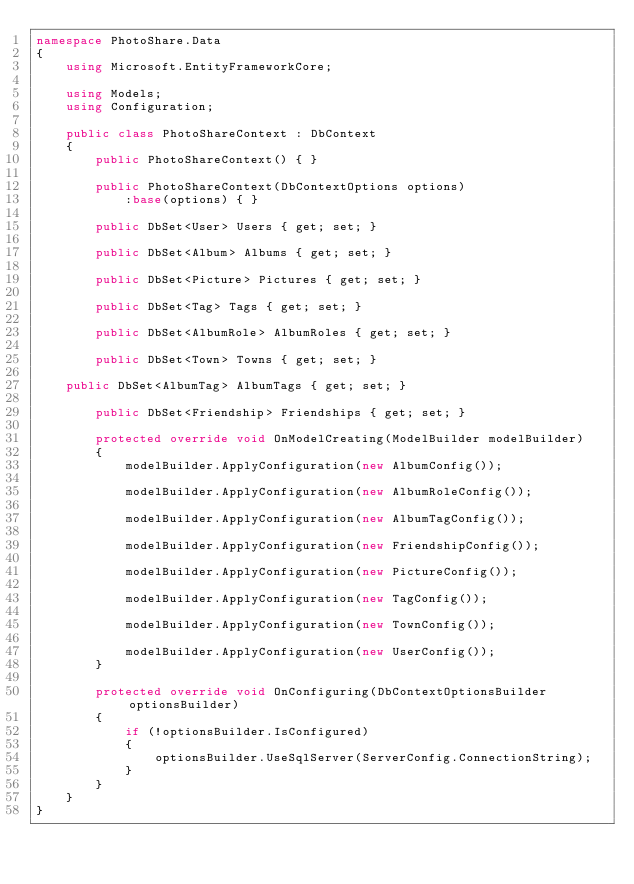<code> <loc_0><loc_0><loc_500><loc_500><_C#_>namespace PhotoShare.Data
{
    using Microsoft.EntityFrameworkCore;

    using Models;
    using Configuration;

    public class PhotoShareContext : DbContext
    { 
        public PhotoShareContext() { }

        public PhotoShareContext(DbContextOptions options)
            :base(options) { }

        public DbSet<User> Users { get; set; }

        public DbSet<Album> Albums { get; set; }

        public DbSet<Picture> Pictures { get; set; }

        public DbSet<Tag> Tags { get; set; }

        public DbSet<AlbumRole> AlbumRoles { get; set; }

        public DbSet<Town> Towns { get; set; }
		
		public DbSet<AlbumTag> AlbumTags { get; set; }

        public DbSet<Friendship> Friendships { get; set; }

        protected override void OnModelCreating(ModelBuilder modelBuilder)
        {
            modelBuilder.ApplyConfiguration(new AlbumConfig());

            modelBuilder.ApplyConfiguration(new AlbumRoleConfig());

            modelBuilder.ApplyConfiguration(new AlbumTagConfig());

            modelBuilder.ApplyConfiguration(new FriendshipConfig());

            modelBuilder.ApplyConfiguration(new PictureConfig());

            modelBuilder.ApplyConfiguration(new TagConfig());

            modelBuilder.ApplyConfiguration(new TownConfig());

            modelBuilder.ApplyConfiguration(new UserConfig());
        }

        protected override void OnConfiguring(DbContextOptionsBuilder optionsBuilder)
        {
            if (!optionsBuilder.IsConfigured)
            {
                optionsBuilder.UseSqlServer(ServerConfig.ConnectionString);
            }
        }
    }
}</code> 